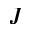Convert formula to latex. <formula><loc_0><loc_0><loc_500><loc_500>J</formula> 